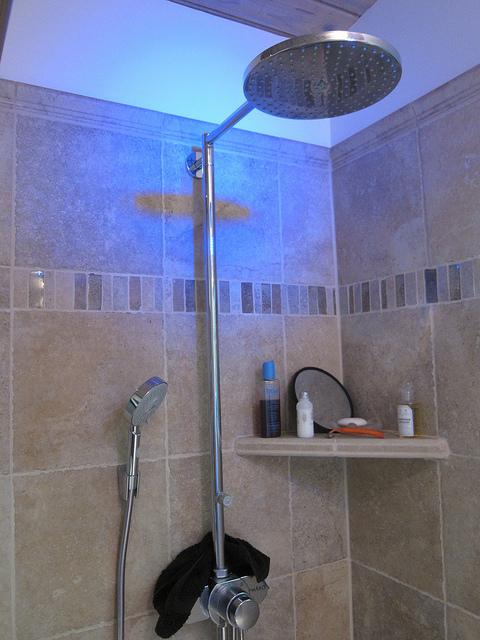What color is background?
Write a very short answer. Tan. What do people do here?
Keep it brief. Shower. Is this a shower?
Answer briefly. Yes. 